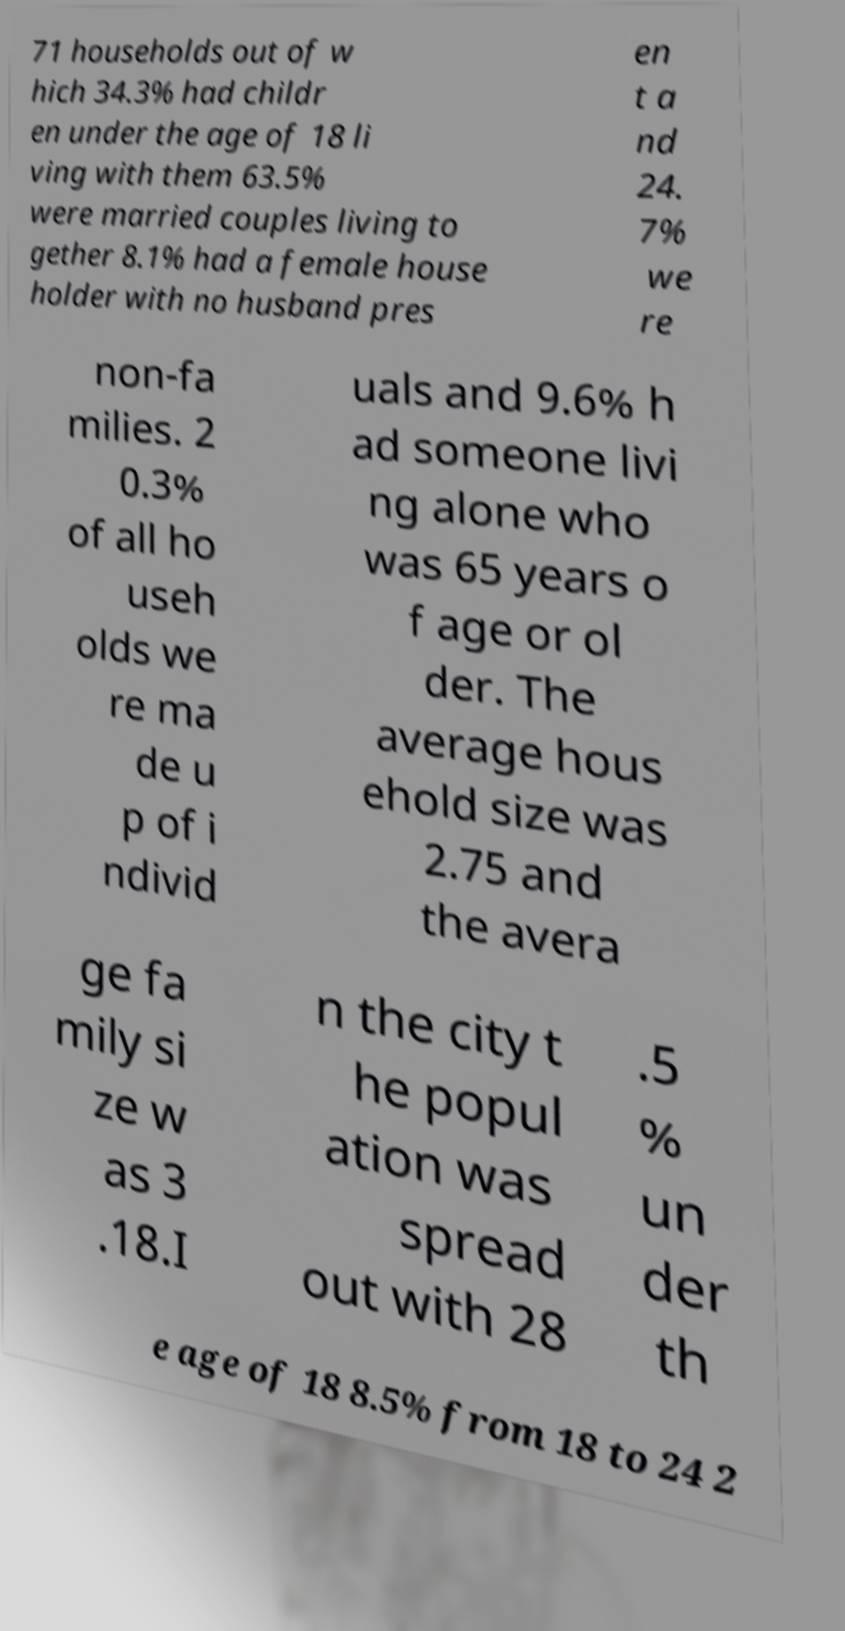For documentation purposes, I need the text within this image transcribed. Could you provide that? 71 households out of w hich 34.3% had childr en under the age of 18 li ving with them 63.5% were married couples living to gether 8.1% had a female house holder with no husband pres en t a nd 24. 7% we re non-fa milies. 2 0.3% of all ho useh olds we re ma de u p of i ndivid uals and 9.6% h ad someone livi ng alone who was 65 years o f age or ol der. The average hous ehold size was 2.75 and the avera ge fa mily si ze w as 3 .18.I n the city t he popul ation was spread out with 28 .5 % un der th e age of 18 8.5% from 18 to 24 2 